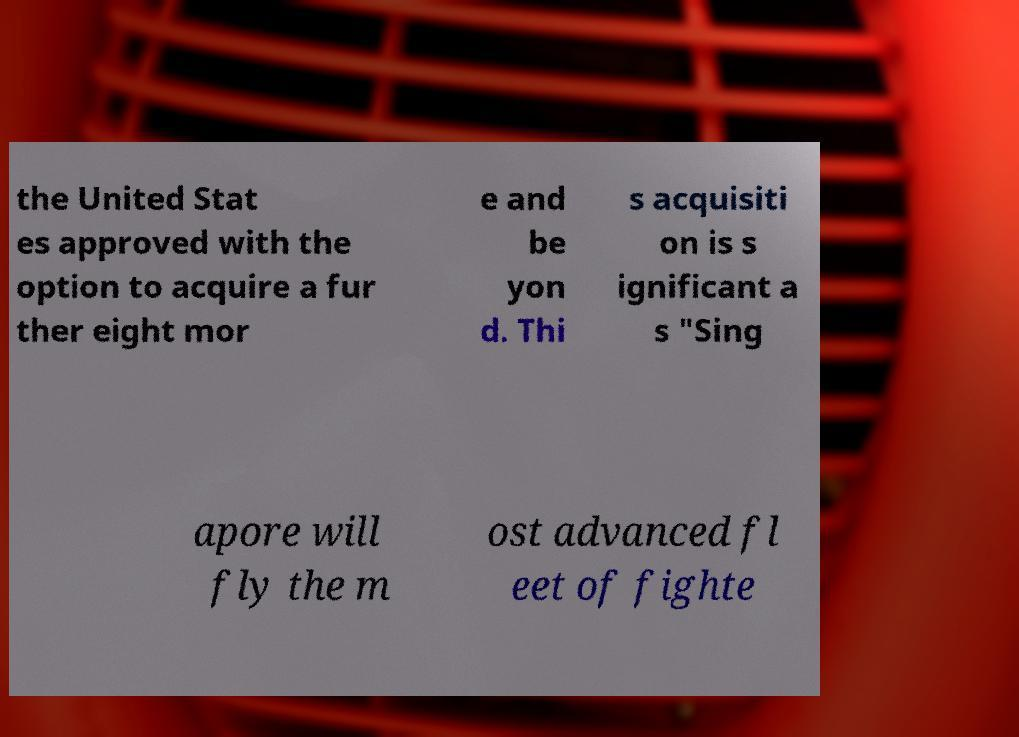There's text embedded in this image that I need extracted. Can you transcribe it verbatim? the United Stat es approved with the option to acquire a fur ther eight mor e and be yon d. Thi s acquisiti on is s ignificant a s "Sing apore will fly the m ost advanced fl eet of fighte 